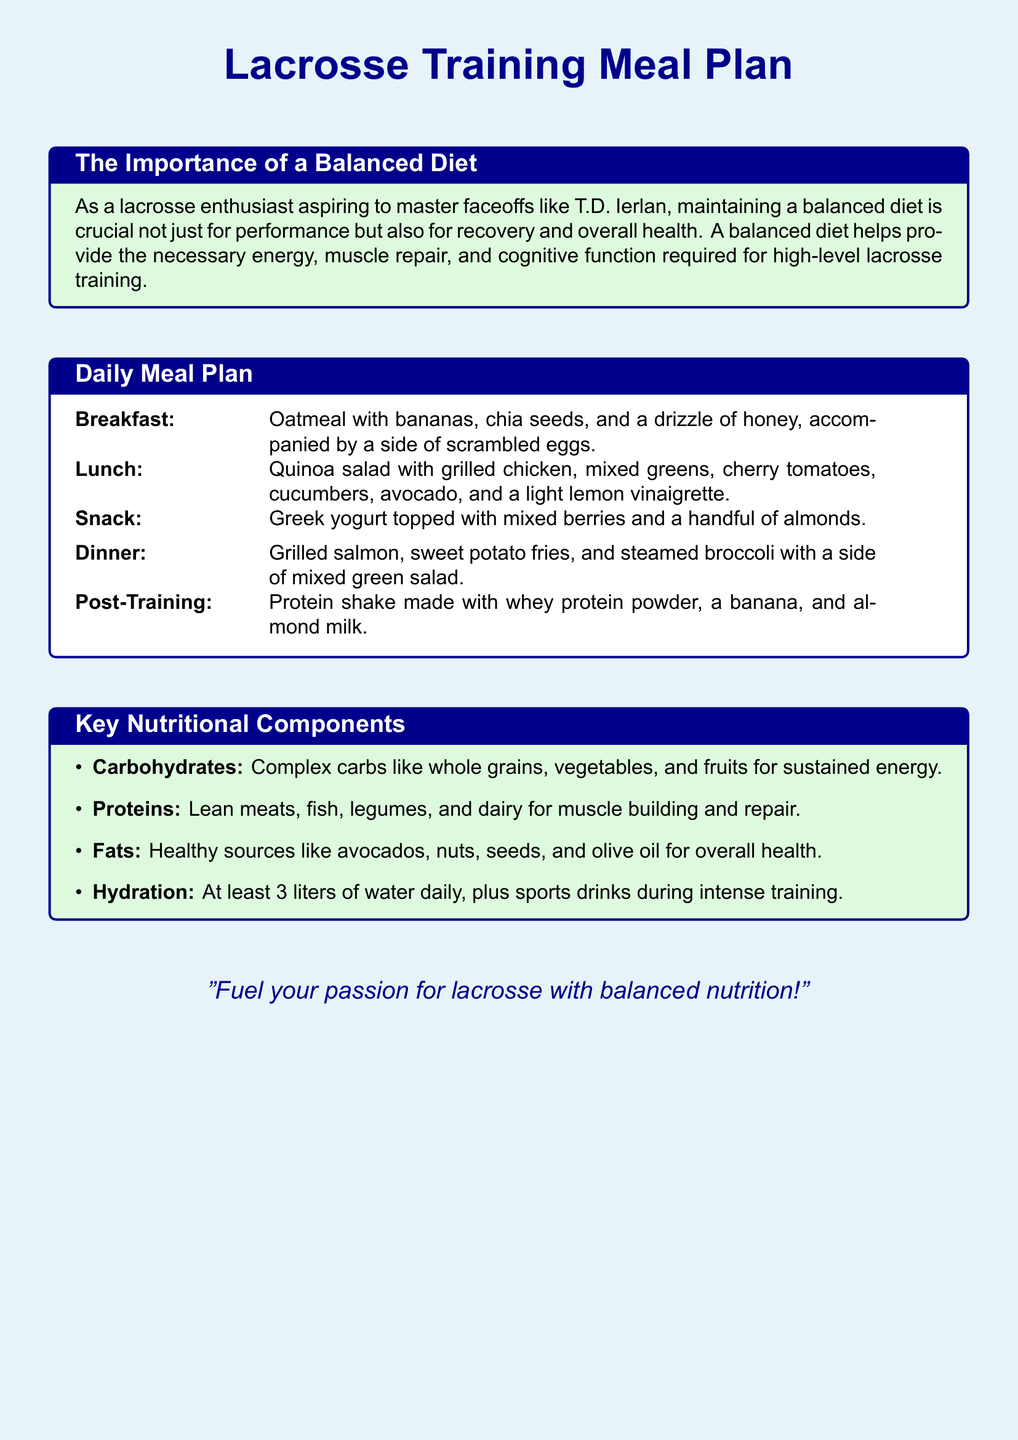What is included in the breakfast? The breakfast consists of oatmeal with bananas, chia seeds, and a drizzle of honey, along with scrambled eggs.
Answer: Oatmeal with bananas, chia seeds, and scrambled eggs What is the main protein source in dinner? The main protein source in the dinner meal is grilled salmon, which is mentioned in the dinner description.
Answer: Grilled salmon How many liters of water should be consumed daily? The document states that at least 3 liters of water should be consumed daily, which is a specific hydration guideline mentioned.
Answer: 3 liters What type of salad is included for lunch? The lunch meal includes a quinoa salad with various ingredients mentioned, including grilled chicken and mixed greens.
Answer: Quinoa salad What is one of the healthy fat sources mentioned? The document lists avocados as one of the healthy fat sources under key nutritional components.
Answer: Avocados What meal is recommended post-training? The post-training meal consists of a protein shake made with whey protein powder, a banana, and almond milk.
Answer: Protein shake What type of carbohydrates are advised for sustained energy? The document states that complex carbs like whole grains, vegetables, and fruits are recommended for sustained energy.
Answer: Complex carbs What is the purpose of a balanced diet according to the document? The document highlights the purpose of a balanced diet as providing necessary energy, muscle repair, and cognitive function for training.
Answer: Performance and recovery 